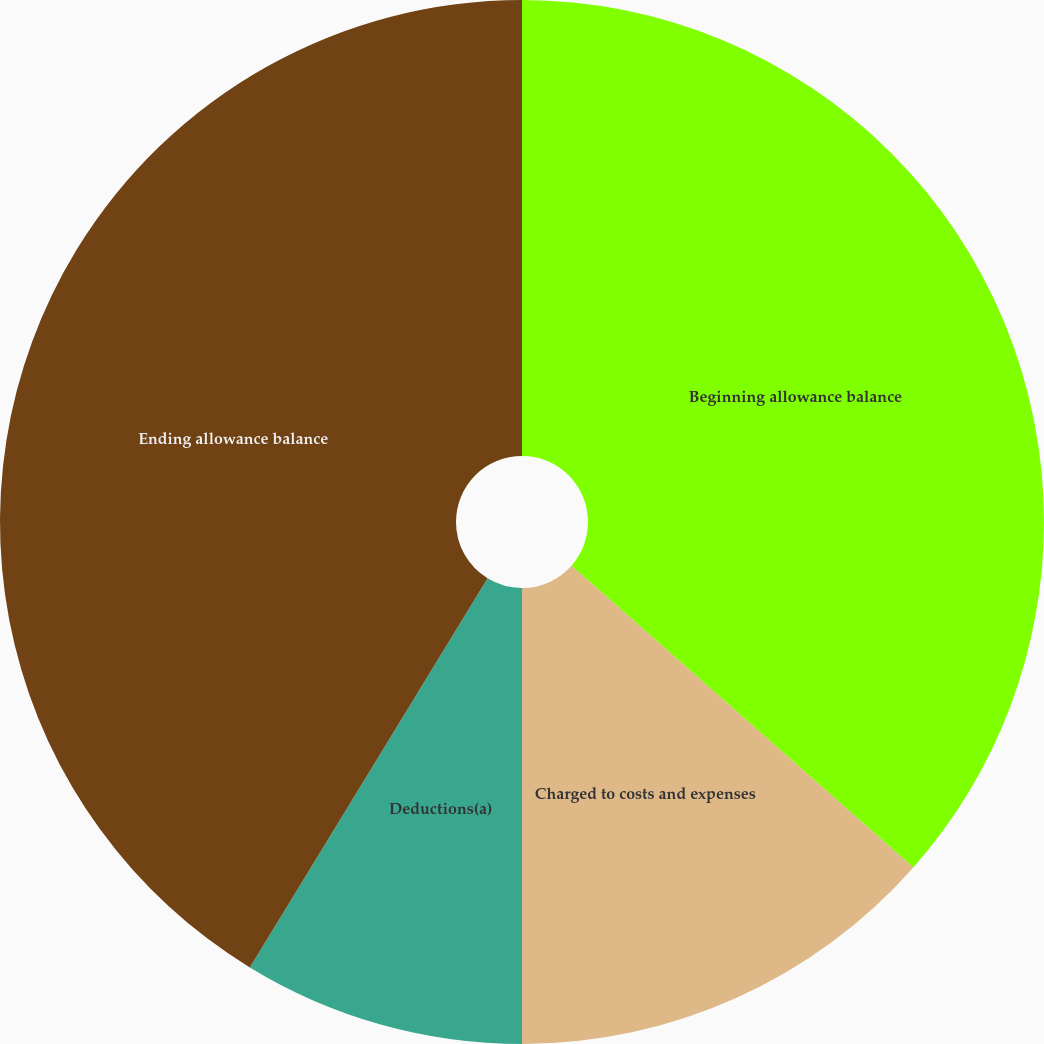Convert chart. <chart><loc_0><loc_0><loc_500><loc_500><pie_chart><fcel>Beginning allowance balance<fcel>Charged to costs and expenses<fcel>Deductions(a)<fcel>Ending allowance balance<nl><fcel>36.51%<fcel>13.49%<fcel>8.73%<fcel>41.27%<nl></chart> 